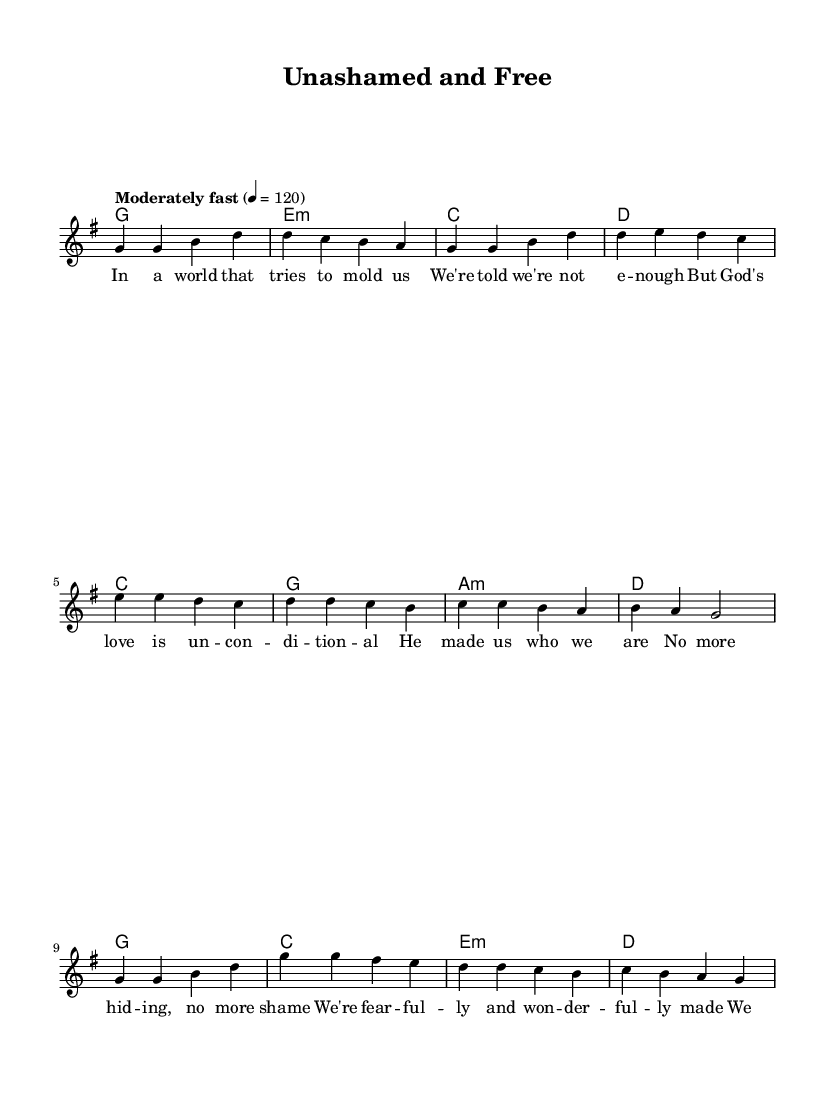What is the key signature of this music? The key signature is G major, which has one sharp (F#). This can be identified by looking at the key signature indicated at the beginning of the staff, which has an F sharp.
Answer: G major What is the time signature of the piece? The time signature is 4/4, visible at the beginning of the staff. This indicates that each measure contains four beats, and the quarter note gets one beat.
Answer: 4/4 What is the tempo marking for this piece? The tempo marking is "Moderately fast" with a metronome marking of 120 beats per minute. This is indicated at the beginning of the score and specifies the speed for the performance.
Answer: Moderately fast How many measures are in the chorus section? The chorus section consists of four measures, as counted from the sheet music where the chorus lyrics begin until they end.
Answer: 4 What is the emotional theme conveyed through the lyrics? The emotional theme conveyed through the lyrics focuses on self-acceptance and embracing one's identity in the light of God's love, as seen in phrases like "unashamed and free" and "we belong." This requires reasoning to interpret the meaning behind the lyrics.
Answer: Self-acceptance What is the first chord of the verse? The first chord of the verse is G major, which is indicated in the harmonies section where the chord names are listed above the melody notes for the verse.
Answer: G How many different chords are used in the pre-chorus? The pre-chorus uses four different chords: C, G, A minor, and D. This can be determined by examining the chord symbols listed above the melody notes in the pre-chorus section.
Answer: 4 